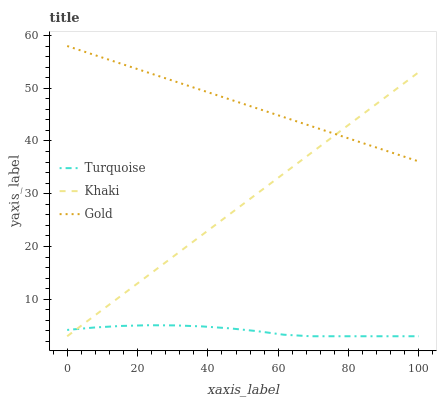Does Turquoise have the minimum area under the curve?
Answer yes or no. Yes. Does Gold have the maximum area under the curve?
Answer yes or no. Yes. Does Khaki have the minimum area under the curve?
Answer yes or no. No. Does Khaki have the maximum area under the curve?
Answer yes or no. No. Is Khaki the smoothest?
Answer yes or no. Yes. Is Turquoise the roughest?
Answer yes or no. Yes. Is Gold the smoothest?
Answer yes or no. No. Is Gold the roughest?
Answer yes or no. No. Does Turquoise have the lowest value?
Answer yes or no. Yes. Does Gold have the lowest value?
Answer yes or no. No. Does Gold have the highest value?
Answer yes or no. Yes. Does Khaki have the highest value?
Answer yes or no. No. Is Turquoise less than Gold?
Answer yes or no. Yes. Is Gold greater than Turquoise?
Answer yes or no. Yes. Does Turquoise intersect Khaki?
Answer yes or no. Yes. Is Turquoise less than Khaki?
Answer yes or no. No. Is Turquoise greater than Khaki?
Answer yes or no. No. Does Turquoise intersect Gold?
Answer yes or no. No. 